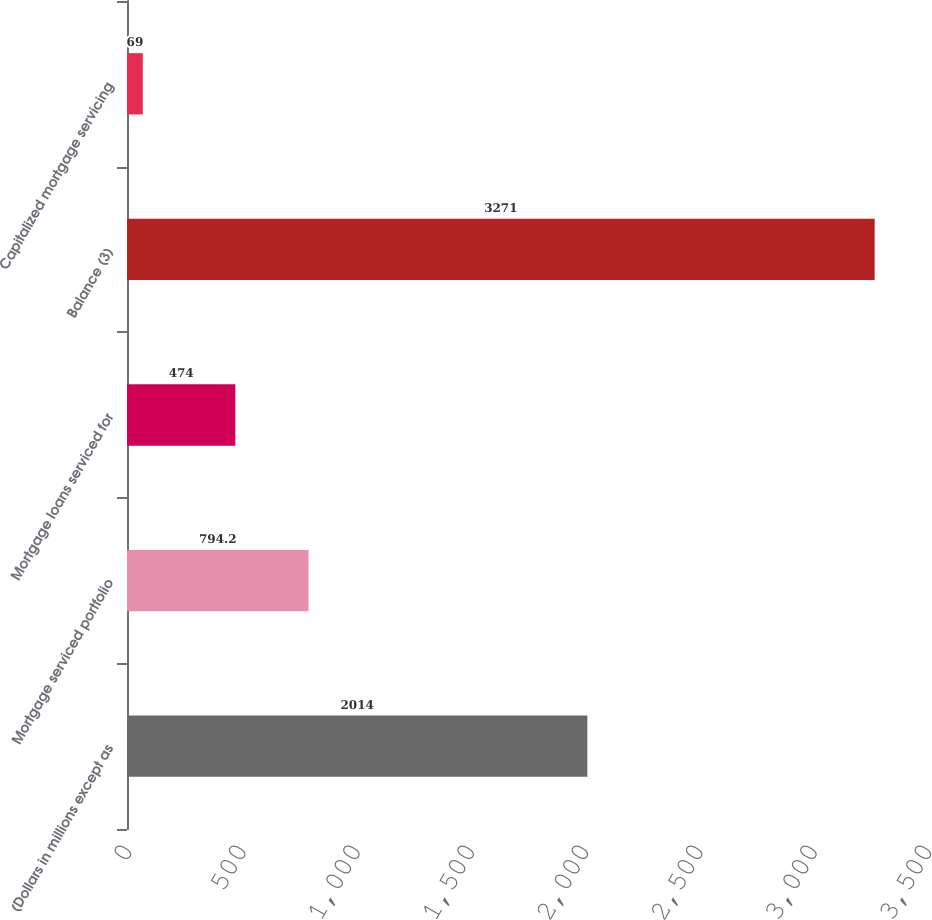Convert chart. <chart><loc_0><loc_0><loc_500><loc_500><bar_chart><fcel>(Dollars in millions except as<fcel>Mortgage serviced portfolio<fcel>Mortgage loans serviced for<fcel>Balance (3)<fcel>Capitalized mortgage servicing<nl><fcel>2014<fcel>794.2<fcel>474<fcel>3271<fcel>69<nl></chart> 